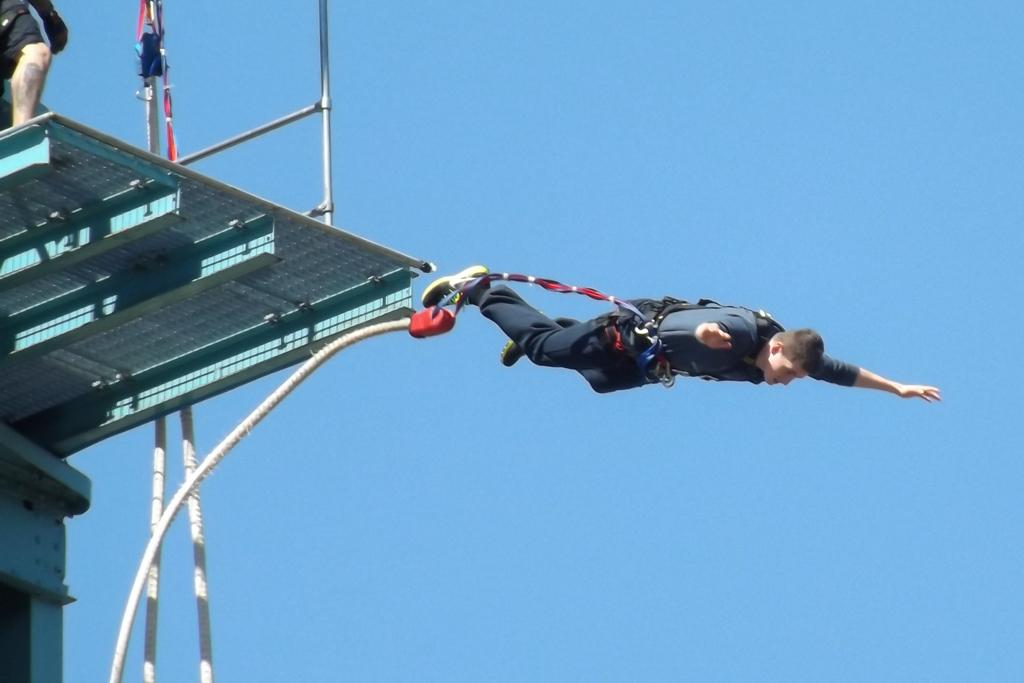What activity is the person in the image engaged in? The person in the image is performing bungee jumping. Can you describe any part of the person's body that is visible in the image? A leg of a person is visible on a stage. What can be seen in the background of the image? The sky is visible in the background of the image. Are there any children playing in the snow in the image? There is no snow or children present in the image. 